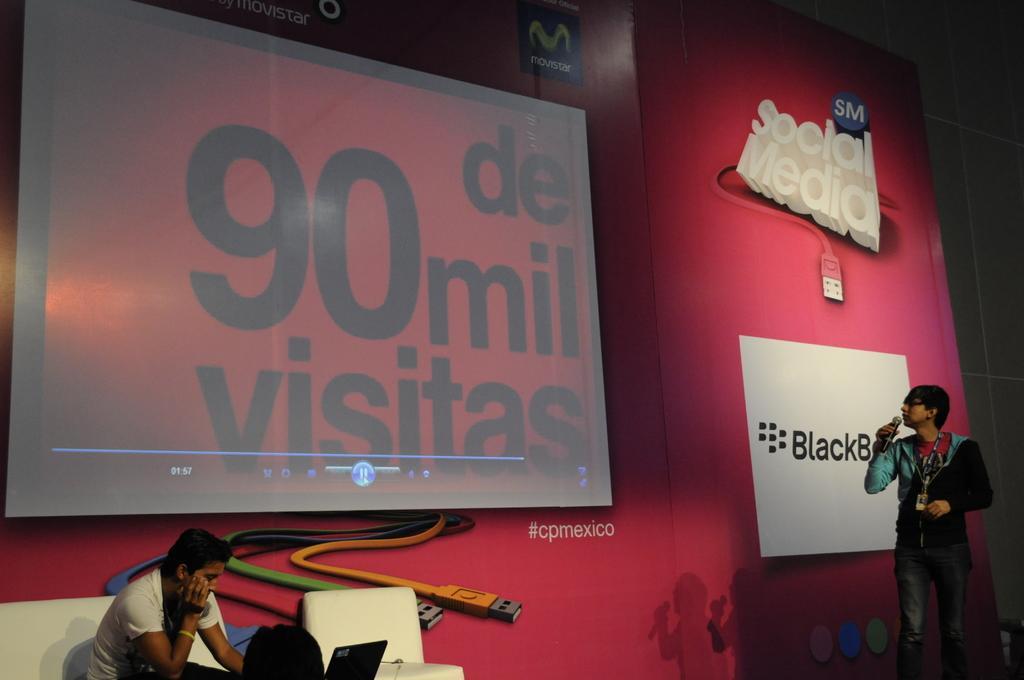Could you give a brief overview of what you see in this image? At the bottom left corner of the image there is a man with white t-shirt is sitting on the white sofa and in front of him there is a laptop. At the right corner of the image there is a man holding a mic and he is standing. In the background there is a red color poster with images and logos. Also there is a screen. 